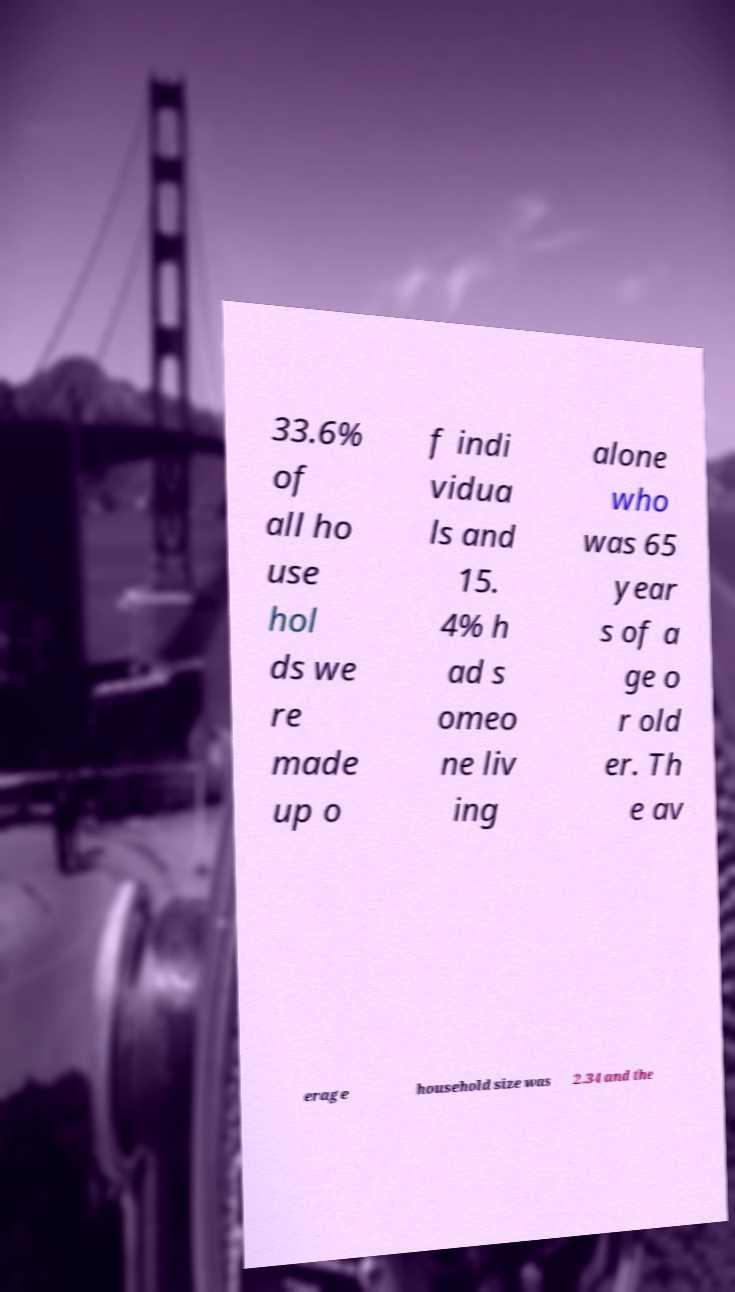I need the written content from this picture converted into text. Can you do that? 33.6% of all ho use hol ds we re made up o f indi vidua ls and 15. 4% h ad s omeo ne liv ing alone who was 65 year s of a ge o r old er. Th e av erage household size was 2.34 and the 